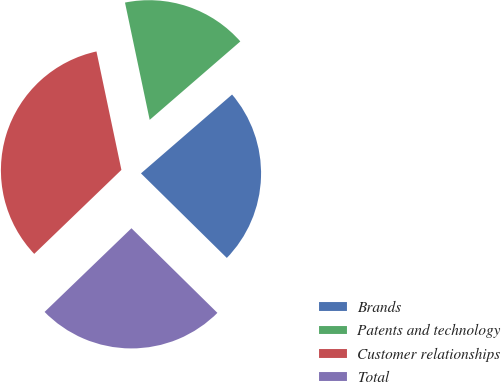Convert chart to OTSL. <chart><loc_0><loc_0><loc_500><loc_500><pie_chart><fcel>Brands<fcel>Patents and technology<fcel>Customer relationships<fcel>Total<nl><fcel>23.73%<fcel>16.95%<fcel>33.9%<fcel>25.42%<nl></chart> 